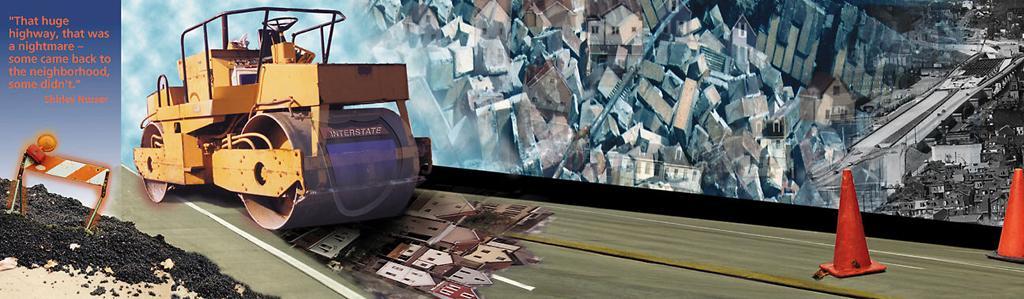Could you give a brief overview of what you see in this image? I see this is a depiction image and I see something is written on the left side of this image and in the middle of this image I see number of buildings and a vehicle and on the right side of this image I see the traffic cones and I see the roads. 